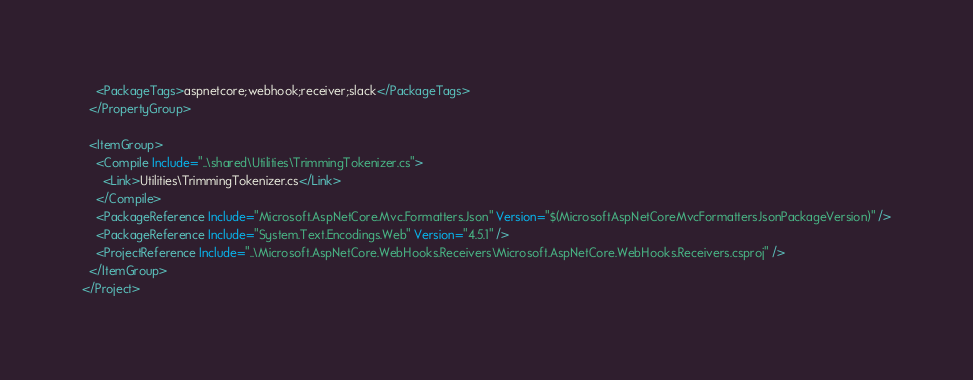<code> <loc_0><loc_0><loc_500><loc_500><_XML_>    <PackageTags>aspnetcore;webhook;receiver;slack</PackageTags>
  </PropertyGroup>

  <ItemGroup>
    <Compile Include="..\shared\Utilities\TrimmingTokenizer.cs">
      <Link>Utilities\TrimmingTokenizer.cs</Link>
    </Compile>
    <PackageReference Include="Microsoft.AspNetCore.Mvc.Formatters.Json" Version="$(MicrosoftAspNetCoreMvcFormattersJsonPackageVersion)" />
    <PackageReference Include="System.Text.Encodings.Web" Version="4.5.1" />
    <ProjectReference Include="..\Microsoft.AspNetCore.WebHooks.Receivers\Microsoft.AspNetCore.WebHooks.Receivers.csproj" />
  </ItemGroup>
</Project>
</code> 